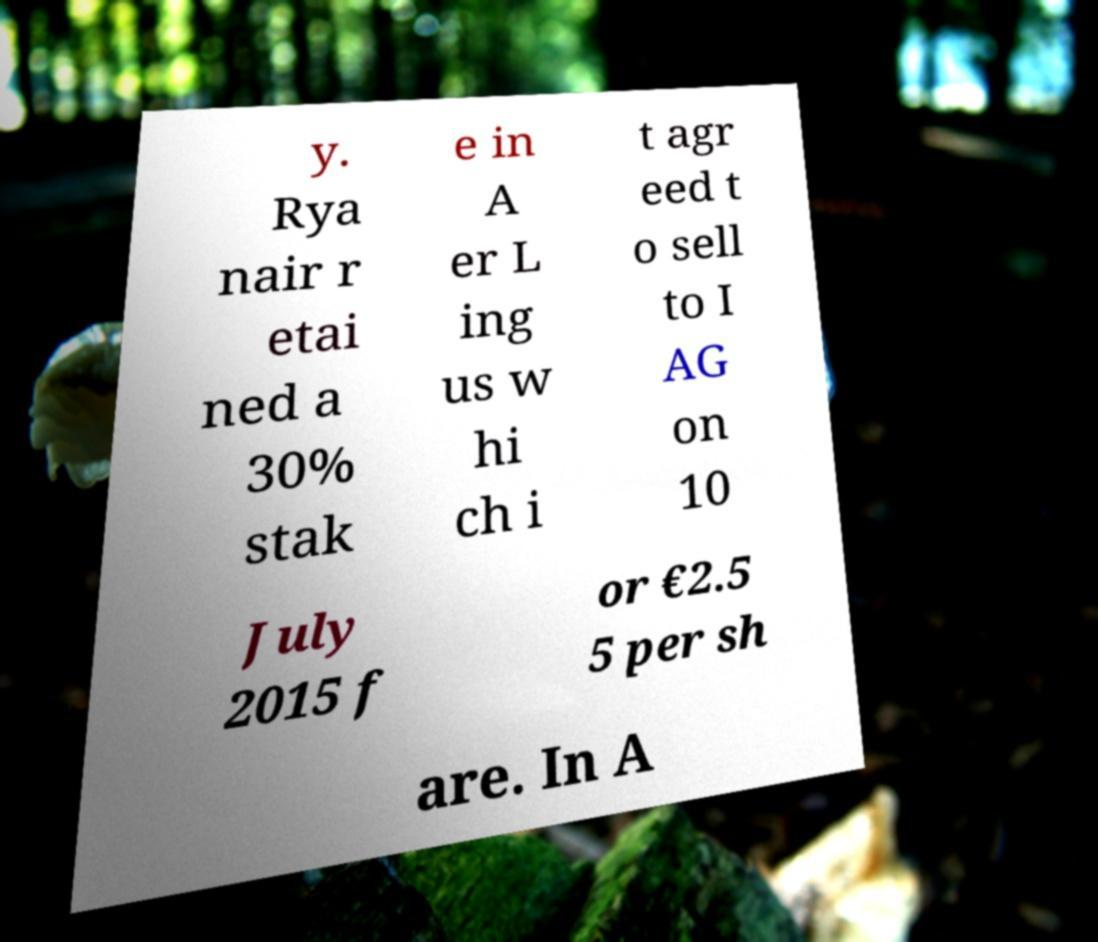There's text embedded in this image that I need extracted. Can you transcribe it verbatim? y. Rya nair r etai ned a 30% stak e in A er L ing us w hi ch i t agr eed t o sell to I AG on 10 July 2015 f or €2.5 5 per sh are. In A 